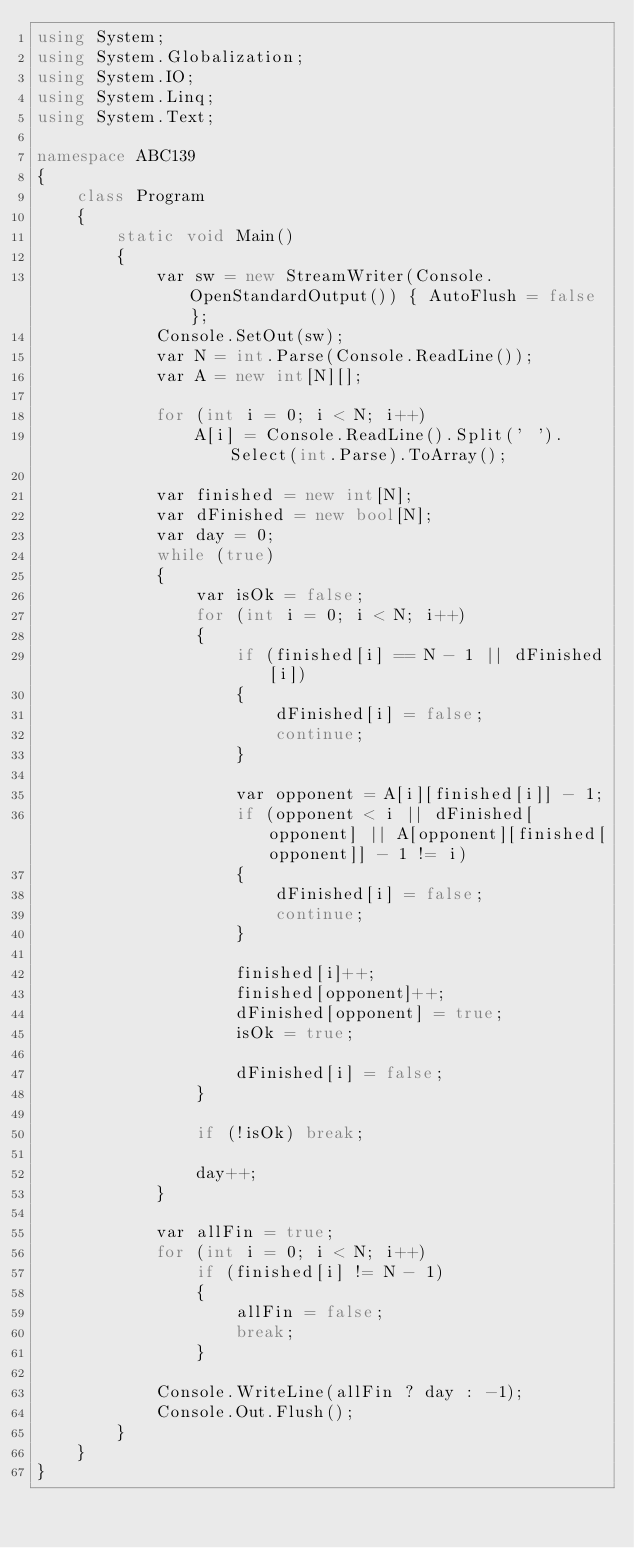<code> <loc_0><loc_0><loc_500><loc_500><_C#_>using System;
using System.Globalization;
using System.IO;
using System.Linq;
using System.Text;

namespace ABC139
{
    class Program
    {
        static void Main()
        {
            var sw = new StreamWriter(Console.OpenStandardOutput()) { AutoFlush = false };
            Console.SetOut(sw);
            var N = int.Parse(Console.ReadLine());
            var A = new int[N][];

            for (int i = 0; i < N; i++)
                A[i] = Console.ReadLine().Split(' ').Select(int.Parse).ToArray();

            var finished = new int[N];
            var dFinished = new bool[N];
            var day = 0;
            while (true)
            {
                var isOk = false;
                for (int i = 0; i < N; i++)
                {
                    if (finished[i] == N - 1 || dFinished[i])
                    {
                        dFinished[i] = false;
                        continue;
                    }

                    var opponent = A[i][finished[i]] - 1;
                    if (opponent < i || dFinished[opponent] || A[opponent][finished[opponent]] - 1 != i)
                    {
                        dFinished[i] = false;
                        continue;
                    }

                    finished[i]++;
                    finished[opponent]++;
                    dFinished[opponent] = true;
                    isOk = true;

                    dFinished[i] = false;
                }

                if (!isOk) break;

                day++;
            }

            var allFin = true;
            for (int i = 0; i < N; i++)
                if (finished[i] != N - 1)
                {
                    allFin = false;
                    break;
                }

            Console.WriteLine(allFin ? day : -1);
            Console.Out.Flush();
        }
    }
}
</code> 